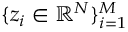Convert formula to latex. <formula><loc_0><loc_0><loc_500><loc_500>\{ z _ { i } \in \mathbb { R } ^ { N } \} _ { i = 1 } ^ { M }</formula> 